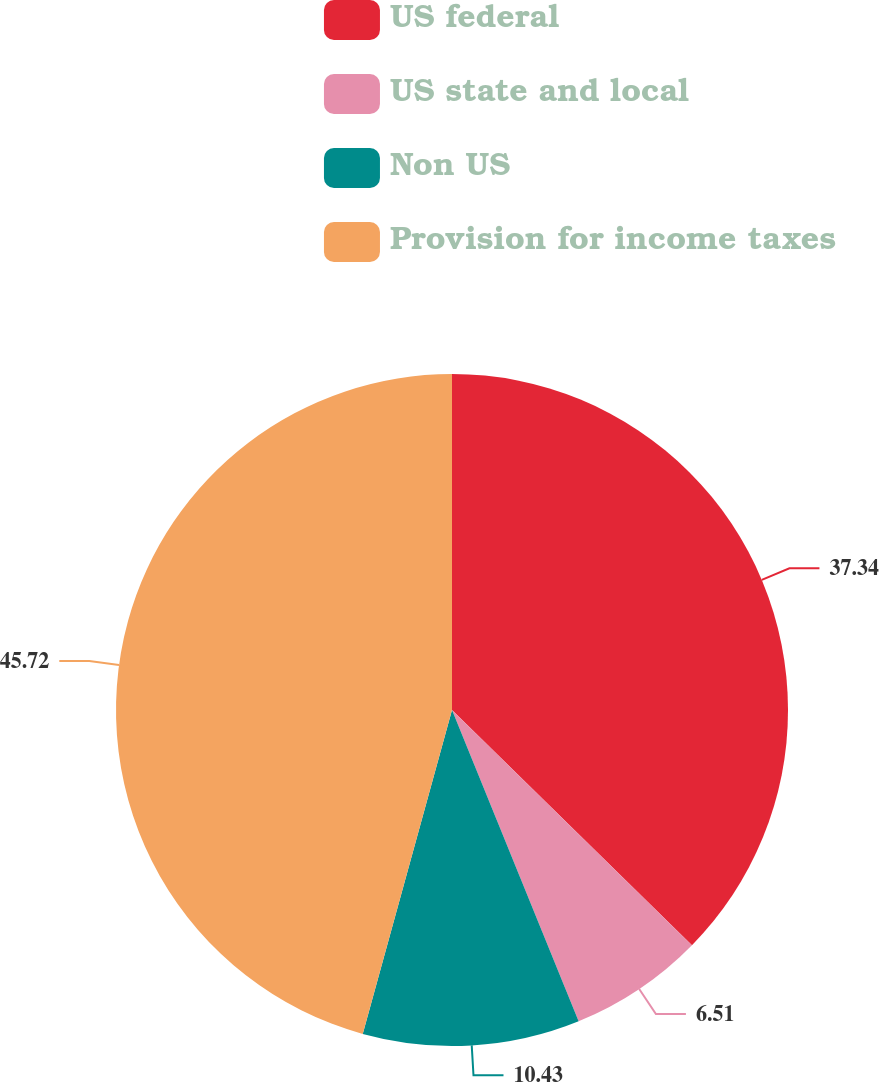Convert chart. <chart><loc_0><loc_0><loc_500><loc_500><pie_chart><fcel>US federal<fcel>US state and local<fcel>Non US<fcel>Provision for income taxes<nl><fcel>37.34%<fcel>6.51%<fcel>10.43%<fcel>45.72%<nl></chart> 